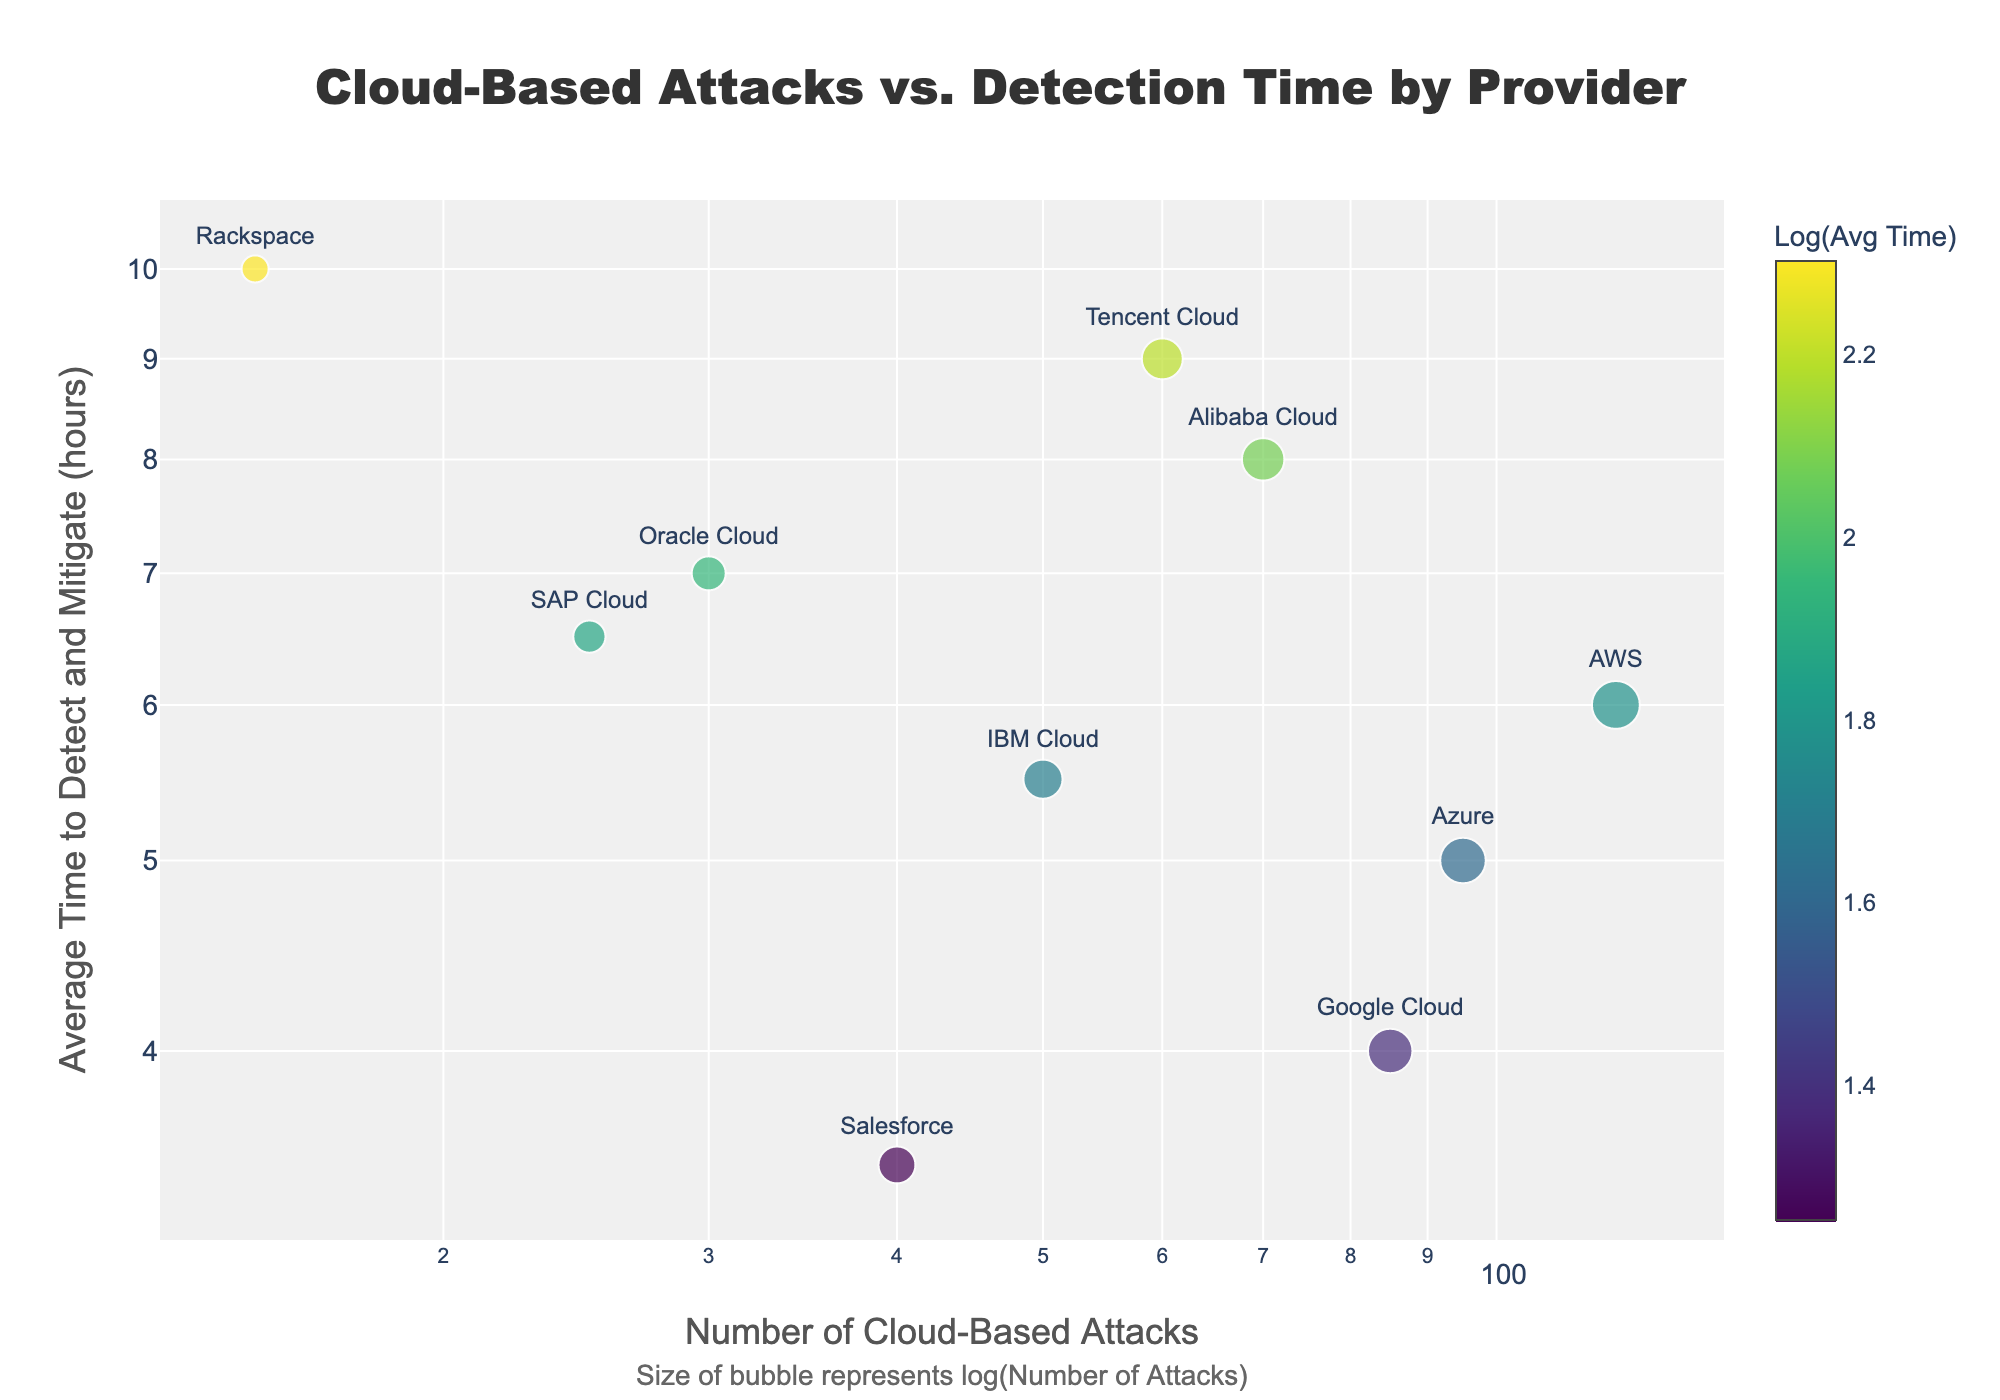What's the title of the plot? The title of the plot is displayed prominently at the top. It reads "Cloud-Based Attacks vs. Detection Time by Provider".
Answer: Cloud-Based Attacks vs. Detection Time by Provider Which cloud provider has the highest number of attacks? The provider with the highest number of attacks will be represented by the rightmost point on the x-axis. According to the data, AWS has 120 attacks, which is the highest.
Answer: AWS What is the average time to detect and mitigate for Salesforce? Look for the data point labeled "Salesforce". According to the data, Salesforce takes an average of 3.5 hours to detect and mitigate.
Answer: 3.5 hours Which cloud provider has the smallest number of attacks? Find the point that is furthest to the left on the x-axis. According to the data, Rackspace has the smallest number of attacks with 15.
Answer: Rackspace Which cloud provider has the longest average time to detect and mitigate? Look for the data point that is highest on the y-axis. According to the data, Rackspace has the longest average time to detect and mitigate at 10 hours.
Answer: Rackspace Is there any provider that detects and mitigates attacks in less than 5 hours? Scan the y-axis for points below the 5-hour mark. According to the data, Google Cloud and Salesforce detect and mitigate in less than 5 hours.
Answer: Google Cloud and Salesforce How many cloud providers have more than 50 attacks but take less than 6 hours to detect and mitigate? Count the number of points that fall to the right of the 50 mark on the x-axis and below the 6-hour mark on the y-axis. Providers fitting these criteria are AWS, Azure, and Google Cloud.
Answer: 3 providers What’s the difference in the average time to detect and mitigate for Tencent Cloud and Oracle Cloud? According to the data, the average time for Tencent Cloud is 9 hours and for Oracle Cloud is 7 hours. The difference is 9 - 7 = 2 hours.
Answer: 2 hours Which cloud provider is represented by the darkest color? The darkest color on the Viridis scale corresponds to the highest log value of "Average Time to Detect and Mitigate". Scan for the darkest-colored point; according to the data, it is Tencent Cloud.
Answer: Tencent Cloud Is there a trend between the number of cloud-based attacks and the average time to detect and mitigate? Observe the overall distribution of points. If the points create a noticeable pattern or trend, it suggests a relationship. Based on the plot, as the number of attacks increases, the average time to detect and mitigate generally decreases.
Answer: Yes, as attacks increase, the average time generally decreases 